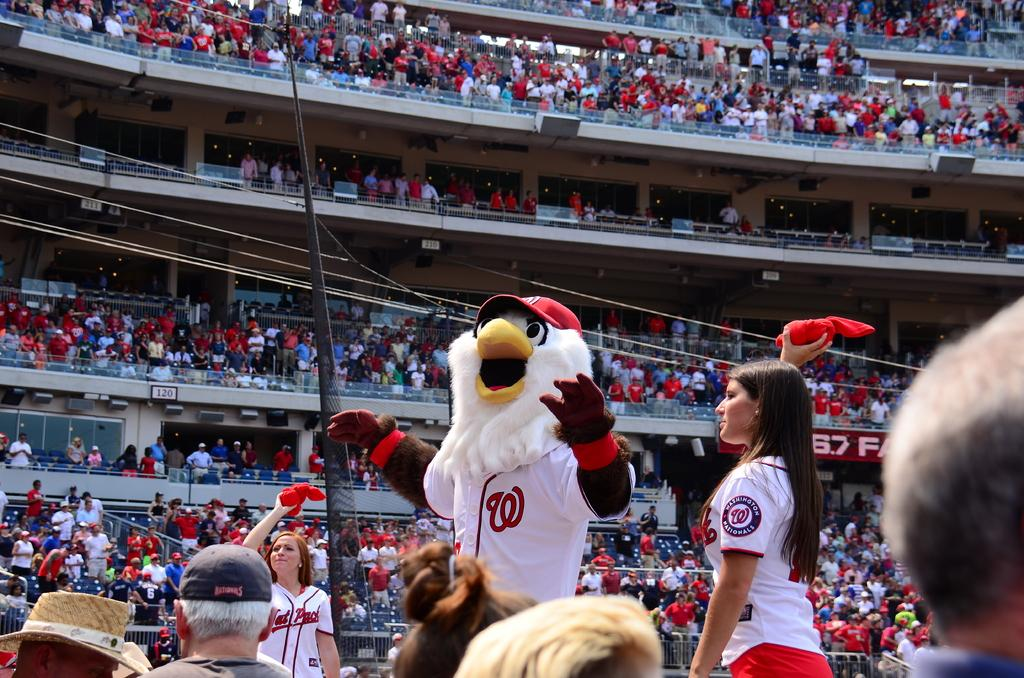<image>
Give a short and clear explanation of the subsequent image. washington national cheerleaders on the field with the mascot 